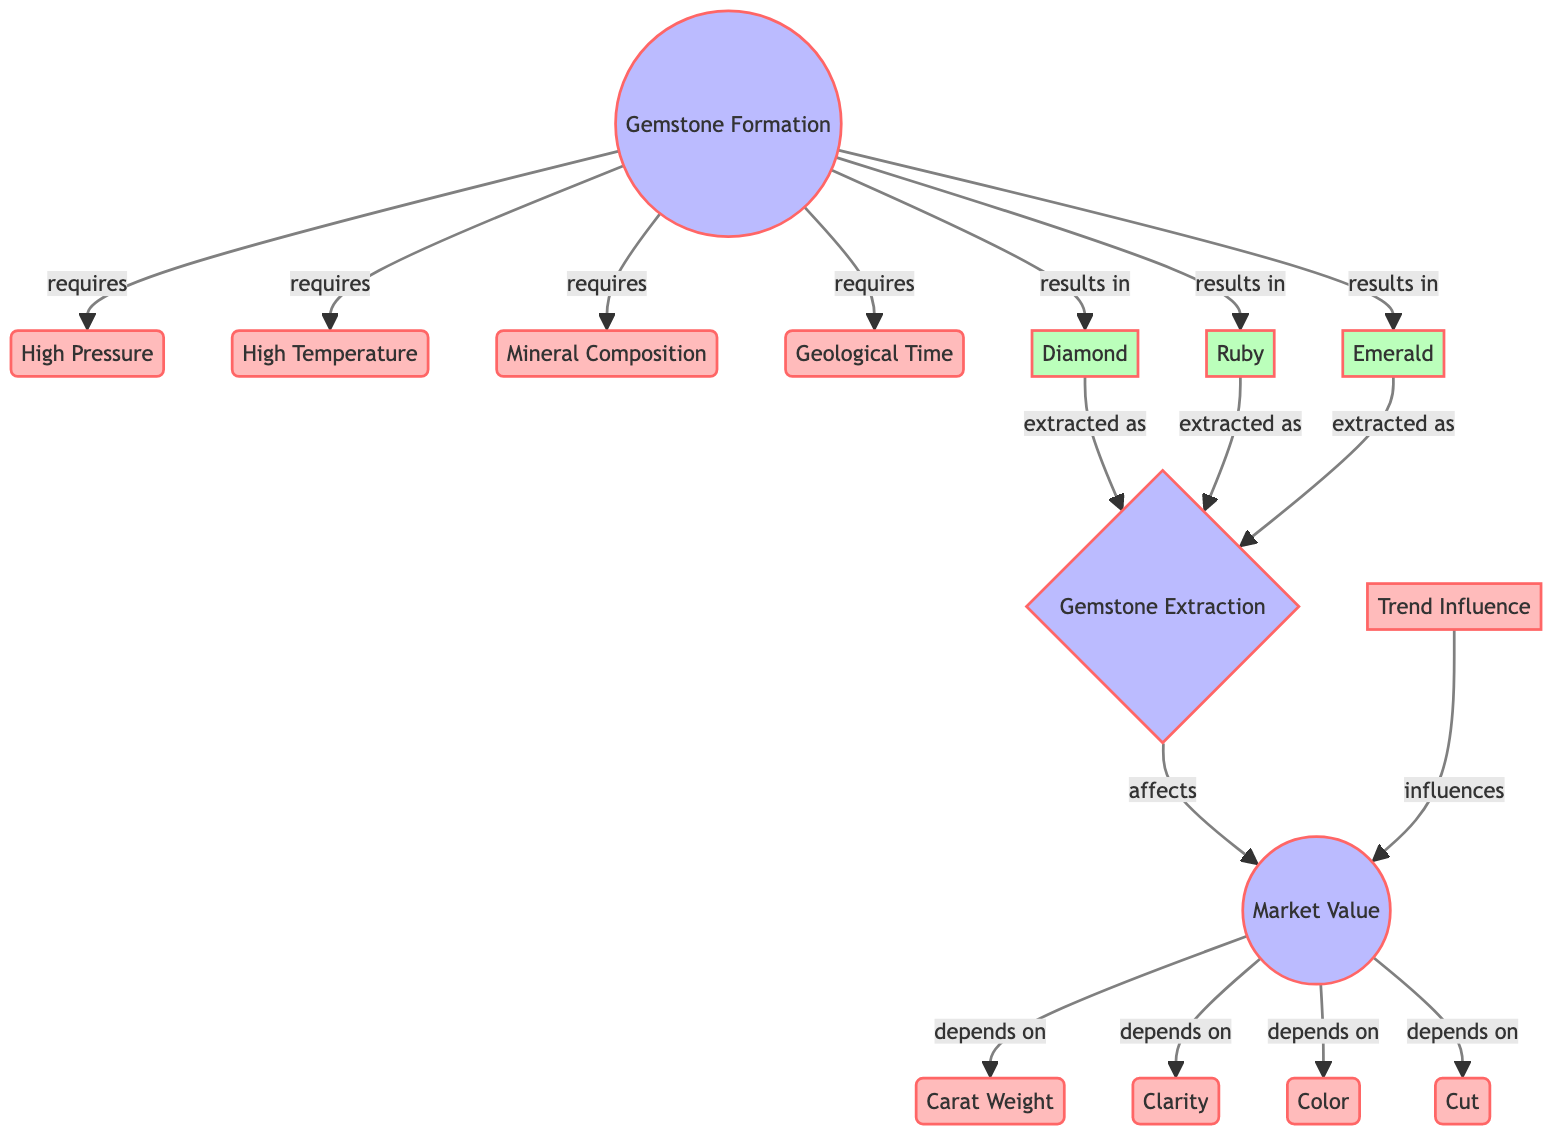What are the four factors required for gemstone formation? The diagram lists four factors under the "Gemstone Formation" node: High Pressure, High Temperature, Mineral Composition, and Geological Time. These factors are indicated by arrows pointing to the "Gemstone Formation" process.
Answer: High Pressure, High Temperature, Mineral Composition, Geological Time How many types of gemstones are mentioned in the diagram? The diagram shows three types of gemstones resulting from gemstone formation: Diamond, Ruby, and Emerald, which are represented as output results.
Answer: Three What does "Gemstone Extraction" affect? The flow from "Gemstone Extraction" leads to "Market Value," which indicates that the extraction of gemstones influences their market value, as shown by the connecting arrows.
Answer: Market Value Which factors influence market value? The diagram indicates four factors that depend on market value: Carat Weight, Clarity, Color, and Cut. These are connected with arrows pointing towards the "Market Value" process.
Answer: Carat Weight, Clarity, Color, Cut What influences the "Market Value" node? The diagram shows a relationship where "Trend Influence" affects "Market Value," as indicated by an arrow pointing from Trend Influence to Market Value.
Answer: Trend Influence What is the primary process that leads to gemstone types? The first process in the flow diagram is "Gemstone Formation," which is indicated as the source leading to the creation of three types of gemstones.
Answer: Gemstone Formation How are "Diamond," "Ruby," and "Emerald" related to gemstone extraction? The diagram indicates a direct relationship where Diamond, Ruby, and Emerald are extracted as outputs from the "Gemstone Extraction" process, as shown by the connecting arrows.
Answer: Extracted as What connects the "Gemstone Extraction" process to "Market Value"? The diagram reveals a flow from "Gemstone Extraction" directly leading into "Market Value," illustrating that the extraction outcomes are a prerequisite to determining market value.
Answer: Affects Which two conditions are necessary alongside mineral composition for gemstone formation? The diagram lists High Pressure and High Temperature alongside Mineral Composition as necessary factors for gemstone formation, with arrows indicating that these conditions are required.
Answer: High Pressure, High Temperature 